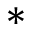<formula> <loc_0><loc_0><loc_500><loc_500>*</formula> 